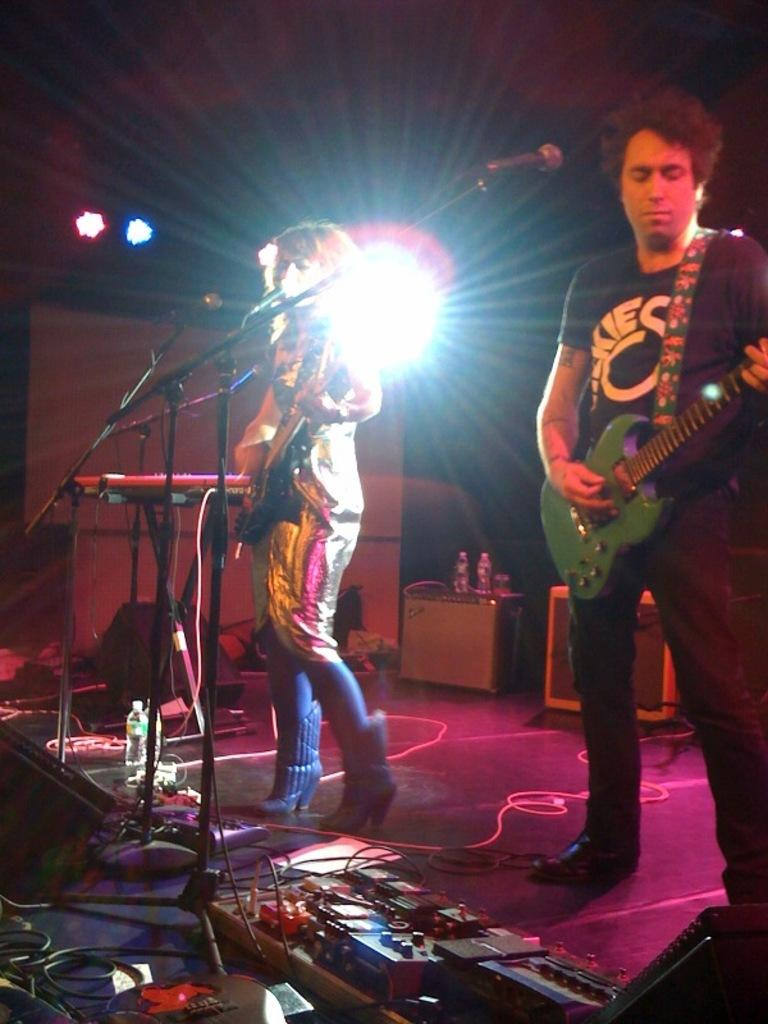How many people are in the image? There are two people in the image. Where are the people located in the image? The two people are standing on a stage. What are the people holding in their hands? The people are holding guitars in their hands. What objects are in front of the people? There are microphones in front of the people. What type of cattle can be seen grazing on the stage in the image? There is no cattle present in the image; it features two people holding guitars on a stage with microphones in front of them. 